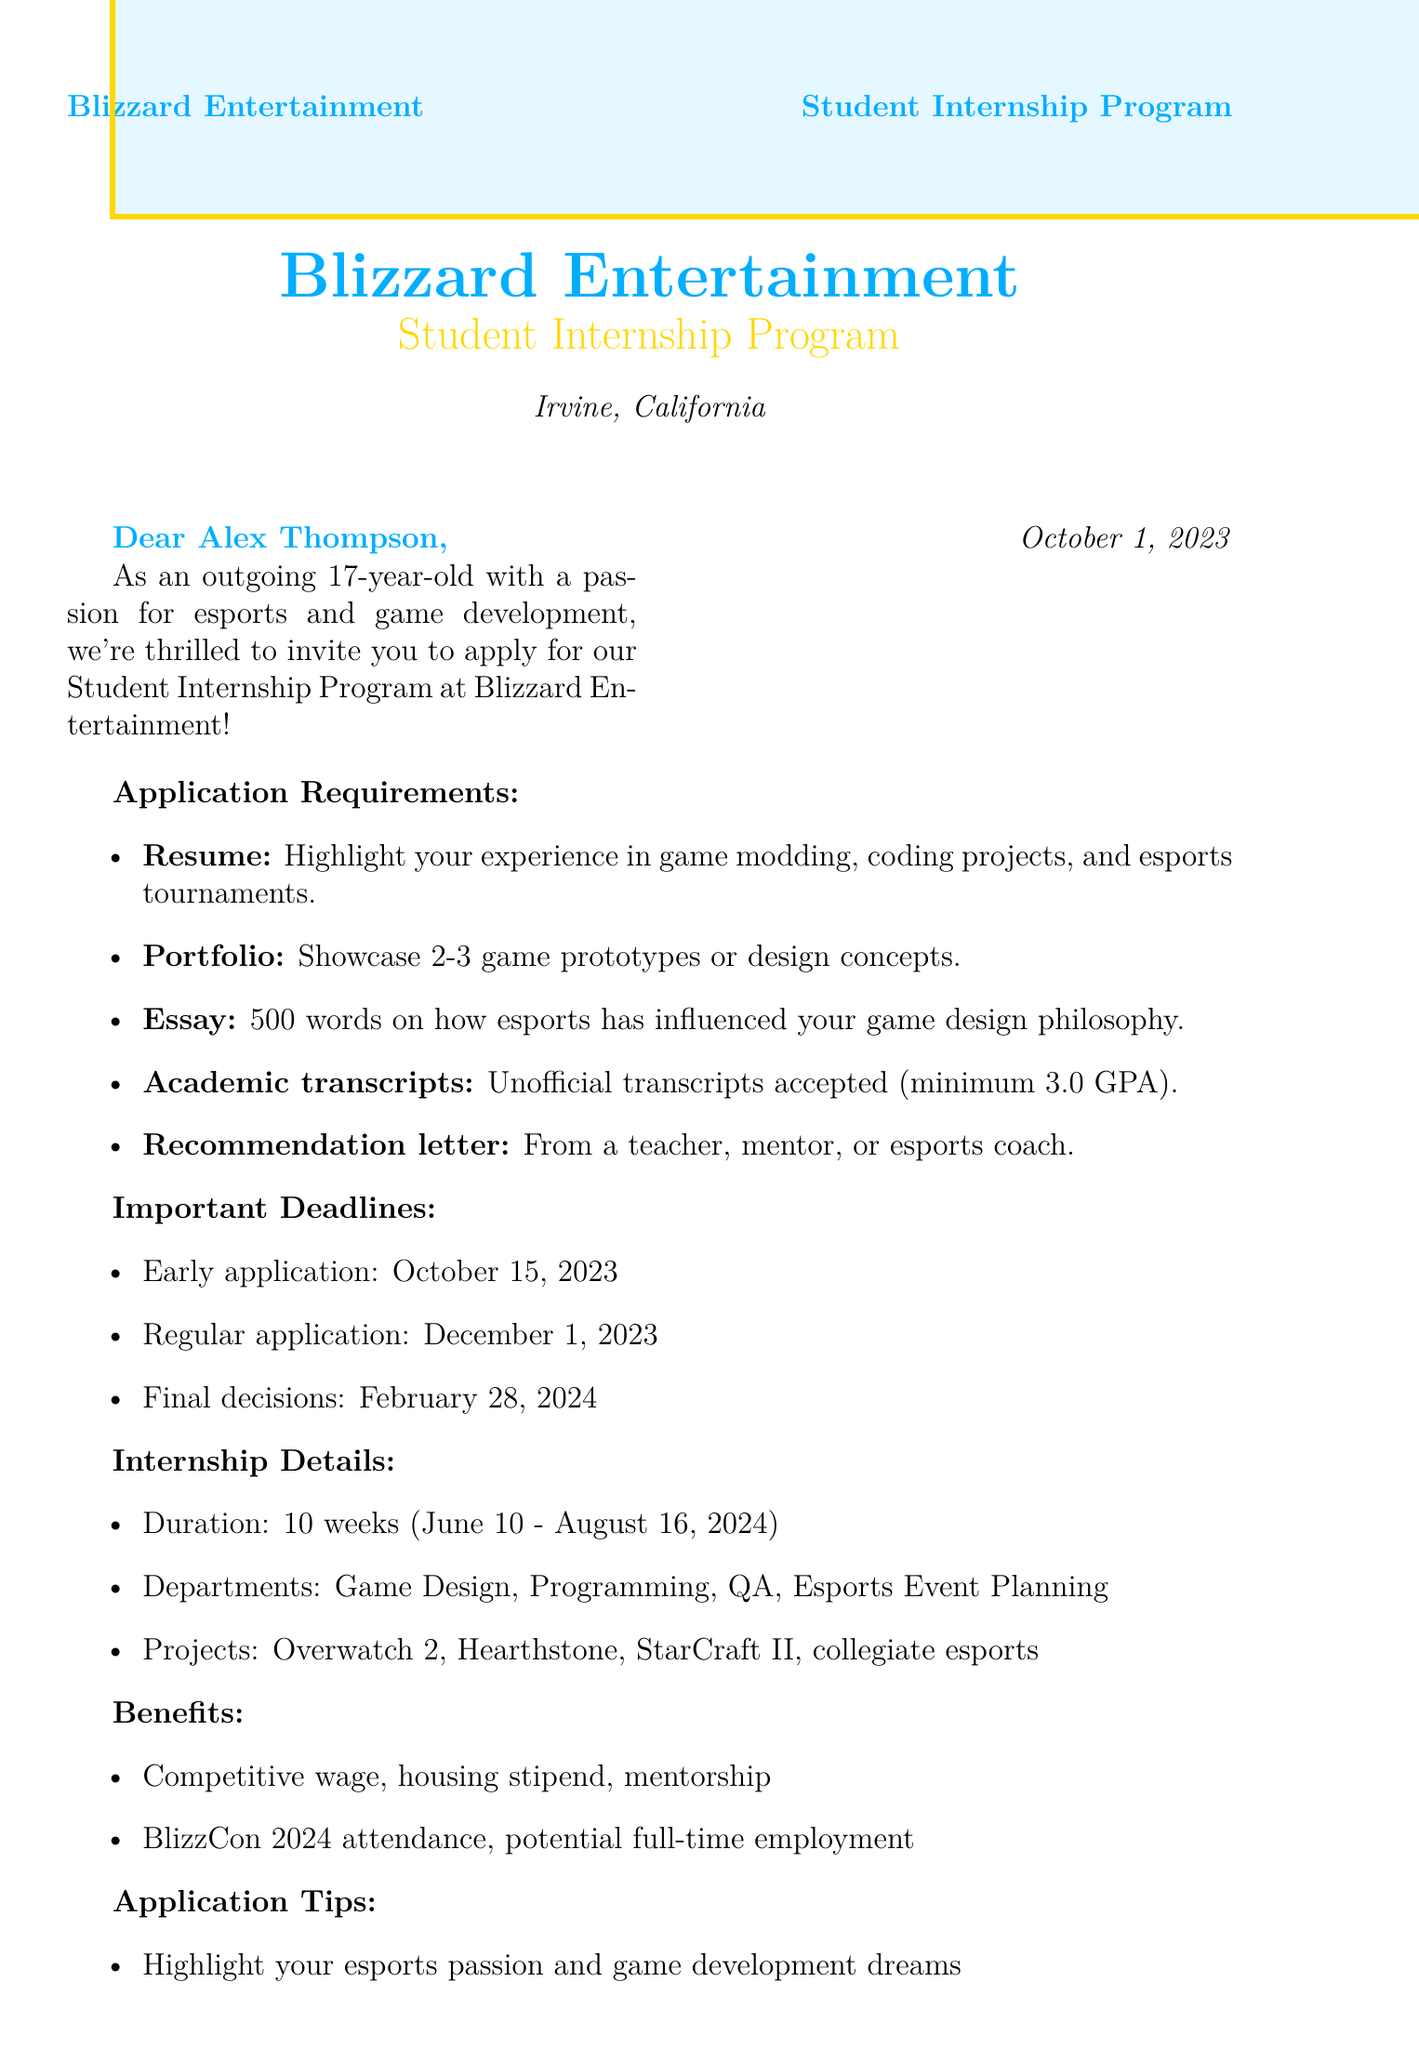What is the name of the internship program? The name of the internship program is stated at the beginning of the document as "Blizzard Entertainment Student Internship Program."
Answer: Blizzard Entertainment Student Internship Program What is the location of the internship? The location is provided in the header of the document, which is Irvine, California.
Answer: Irvine, California What is the minimum GPA requirement? The document mentions that a minimum GPA of 3.0 is required as part of the application requirements.
Answer: 3.0 By when is the early application deadline? The early application deadline is specified as October 15, 2023.
Answer: October 15, 2023 What is one project interns will contribute to? One of the projects mentioned in the document is to contribute to the ongoing development of Overwatch 2.
Answer: Overwatch 2 What are the benefits mentioned for interns? The benefits include a competitive hourly wage, housing stipend, and mentorship from industry professionals.
Answer: Competitive hourly wage What is the duration of the internship? The internship duration is specified as 10 weeks in the details section of the document.
Answer: 10 weeks What is required in the letter of recommendation? The requirement for the letter of recommendation is that it must come from a teacher, mentor, or esports coach.
Answer: Teacher, mentor, or esports coach What is one application tip provided? One of the tips suggests to highlight your passion for esports in your application materials.
Answer: Highlight your passion for esports 